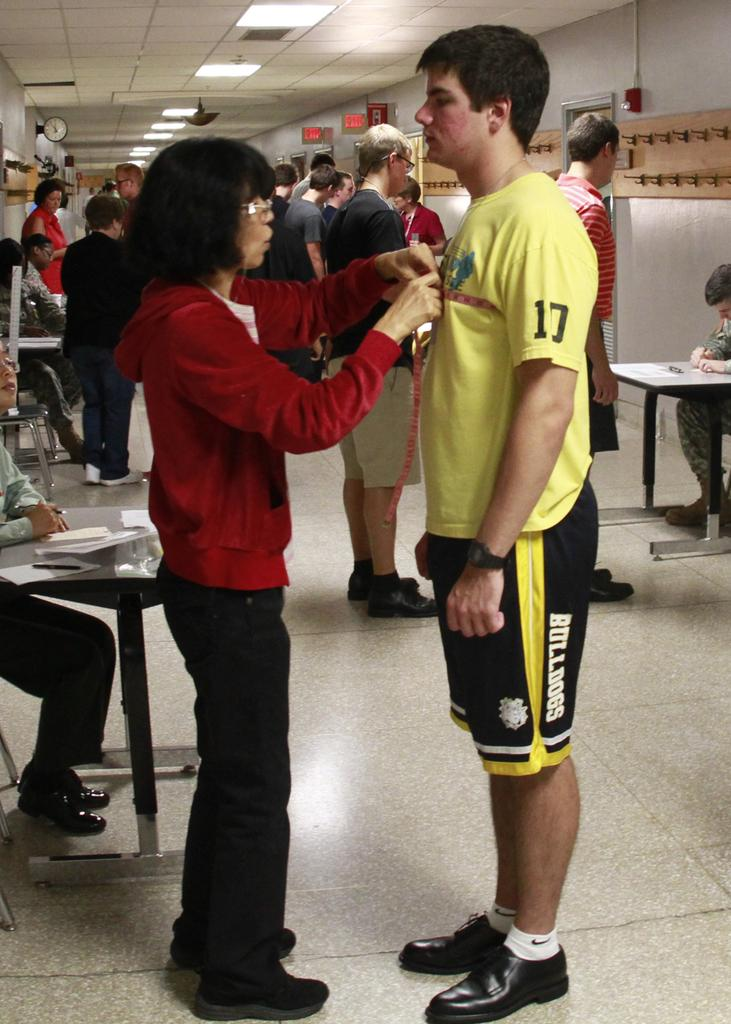Who are the two people in the image? There is a woman and a man in the image. What is the woman holding in her hands? The woman is holding an object in her hands. Can you describe the scene in the background of the image? There are many people in the background of the image. What type of waves can be seen in the image? There are no waves present in the image. How many eggs are visible in the image? There are no eggs visible in the image. 